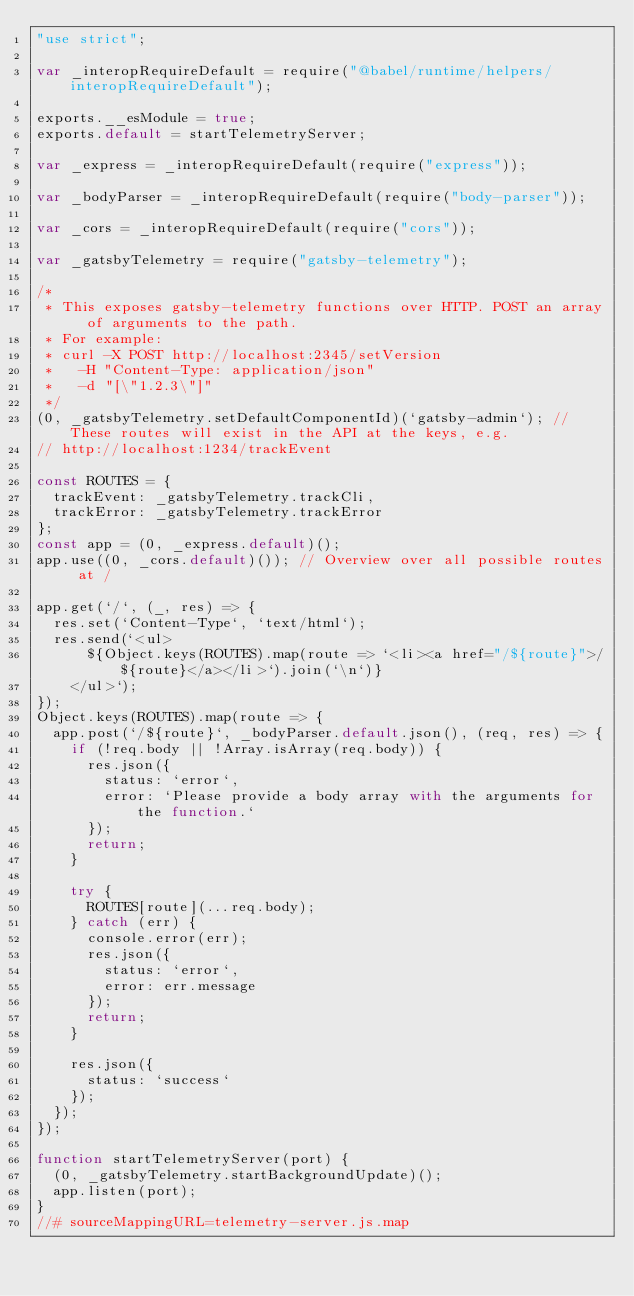<code> <loc_0><loc_0><loc_500><loc_500><_JavaScript_>"use strict";

var _interopRequireDefault = require("@babel/runtime/helpers/interopRequireDefault");

exports.__esModule = true;
exports.default = startTelemetryServer;

var _express = _interopRequireDefault(require("express"));

var _bodyParser = _interopRequireDefault(require("body-parser"));

var _cors = _interopRequireDefault(require("cors"));

var _gatsbyTelemetry = require("gatsby-telemetry");

/*
 * This exposes gatsby-telemetry functions over HTTP. POST an array of arguments to the path.
 * For example:
 * curl -X POST http://localhost:2345/setVersion
 *   -H "Content-Type: application/json"
 *   -d "[\"1.2.3\"]"
 */
(0, _gatsbyTelemetry.setDefaultComponentId)(`gatsby-admin`); // These routes will exist in the API at the keys, e.g.
// http://localhost:1234/trackEvent

const ROUTES = {
  trackEvent: _gatsbyTelemetry.trackCli,
  trackError: _gatsbyTelemetry.trackError
};
const app = (0, _express.default)();
app.use((0, _cors.default)()); // Overview over all possible routes at /

app.get(`/`, (_, res) => {
  res.set(`Content-Type`, `text/html`);
  res.send(`<ul>
      ${Object.keys(ROUTES).map(route => `<li><a href="/${route}">/${route}</a></li>`).join(`\n`)}
    </ul>`);
});
Object.keys(ROUTES).map(route => {
  app.post(`/${route}`, _bodyParser.default.json(), (req, res) => {
    if (!req.body || !Array.isArray(req.body)) {
      res.json({
        status: `error`,
        error: `Please provide a body array with the arguments for the function.`
      });
      return;
    }

    try {
      ROUTES[route](...req.body);
    } catch (err) {
      console.error(err);
      res.json({
        status: `error`,
        error: err.message
      });
      return;
    }

    res.json({
      status: `success`
    });
  });
});

function startTelemetryServer(port) {
  (0, _gatsbyTelemetry.startBackgroundUpdate)();
  app.listen(port);
}
//# sourceMappingURL=telemetry-server.js.map</code> 